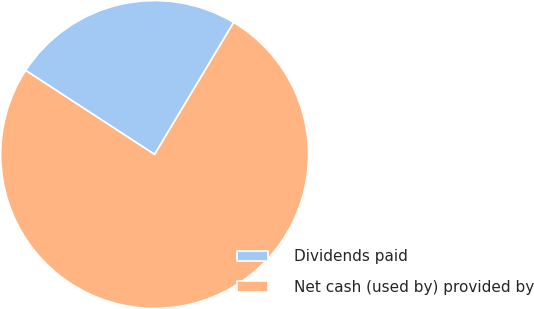Convert chart to OTSL. <chart><loc_0><loc_0><loc_500><loc_500><pie_chart><fcel>Dividends paid<fcel>Net cash (used by) provided by<nl><fcel>24.4%<fcel>75.6%<nl></chart> 